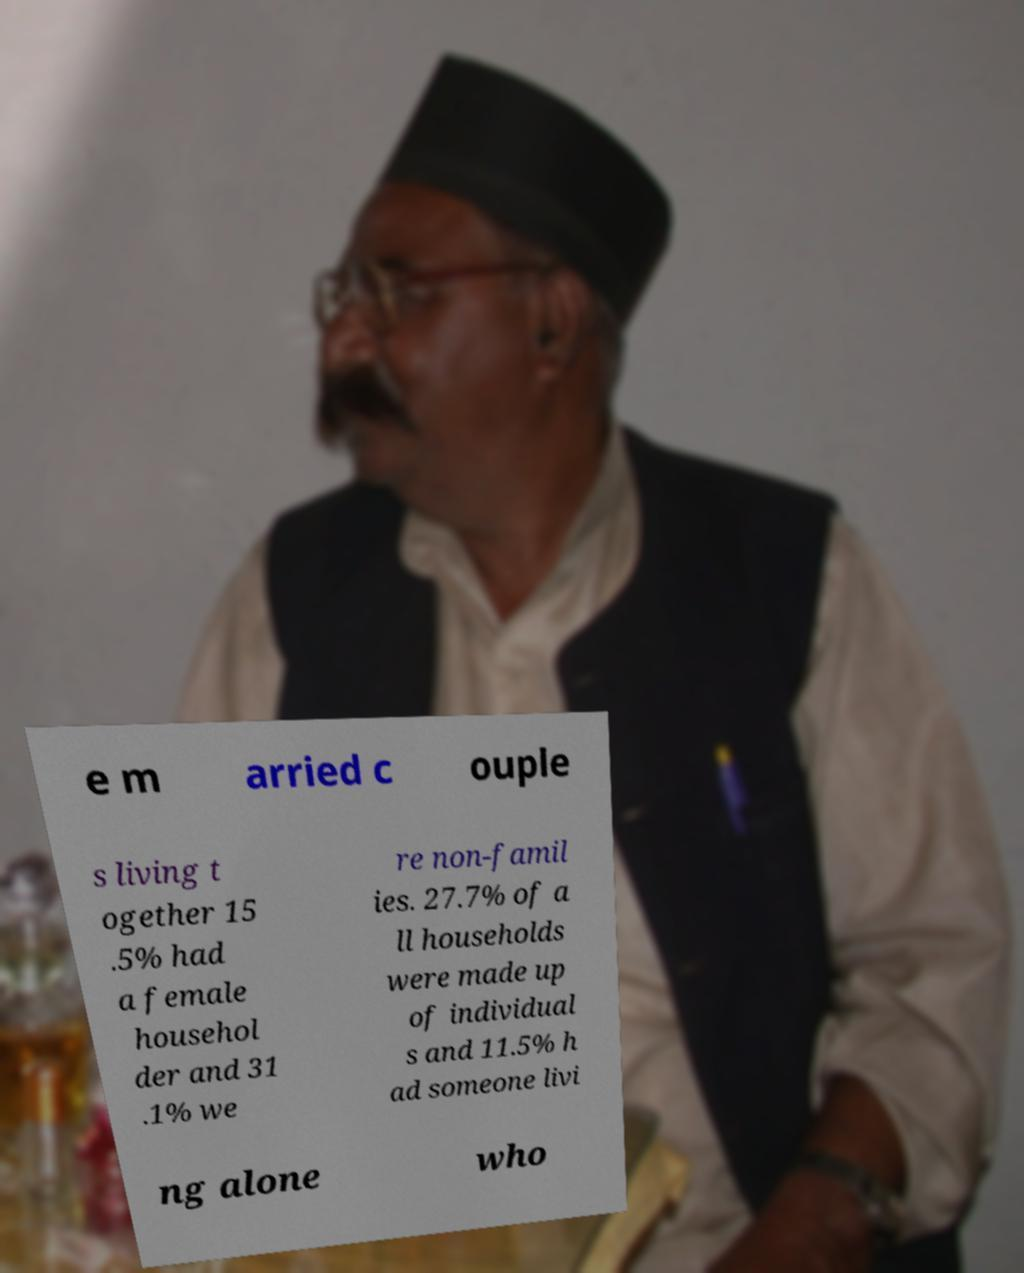For documentation purposes, I need the text within this image transcribed. Could you provide that? e m arried c ouple s living t ogether 15 .5% had a female househol der and 31 .1% we re non-famil ies. 27.7% of a ll households were made up of individual s and 11.5% h ad someone livi ng alone who 